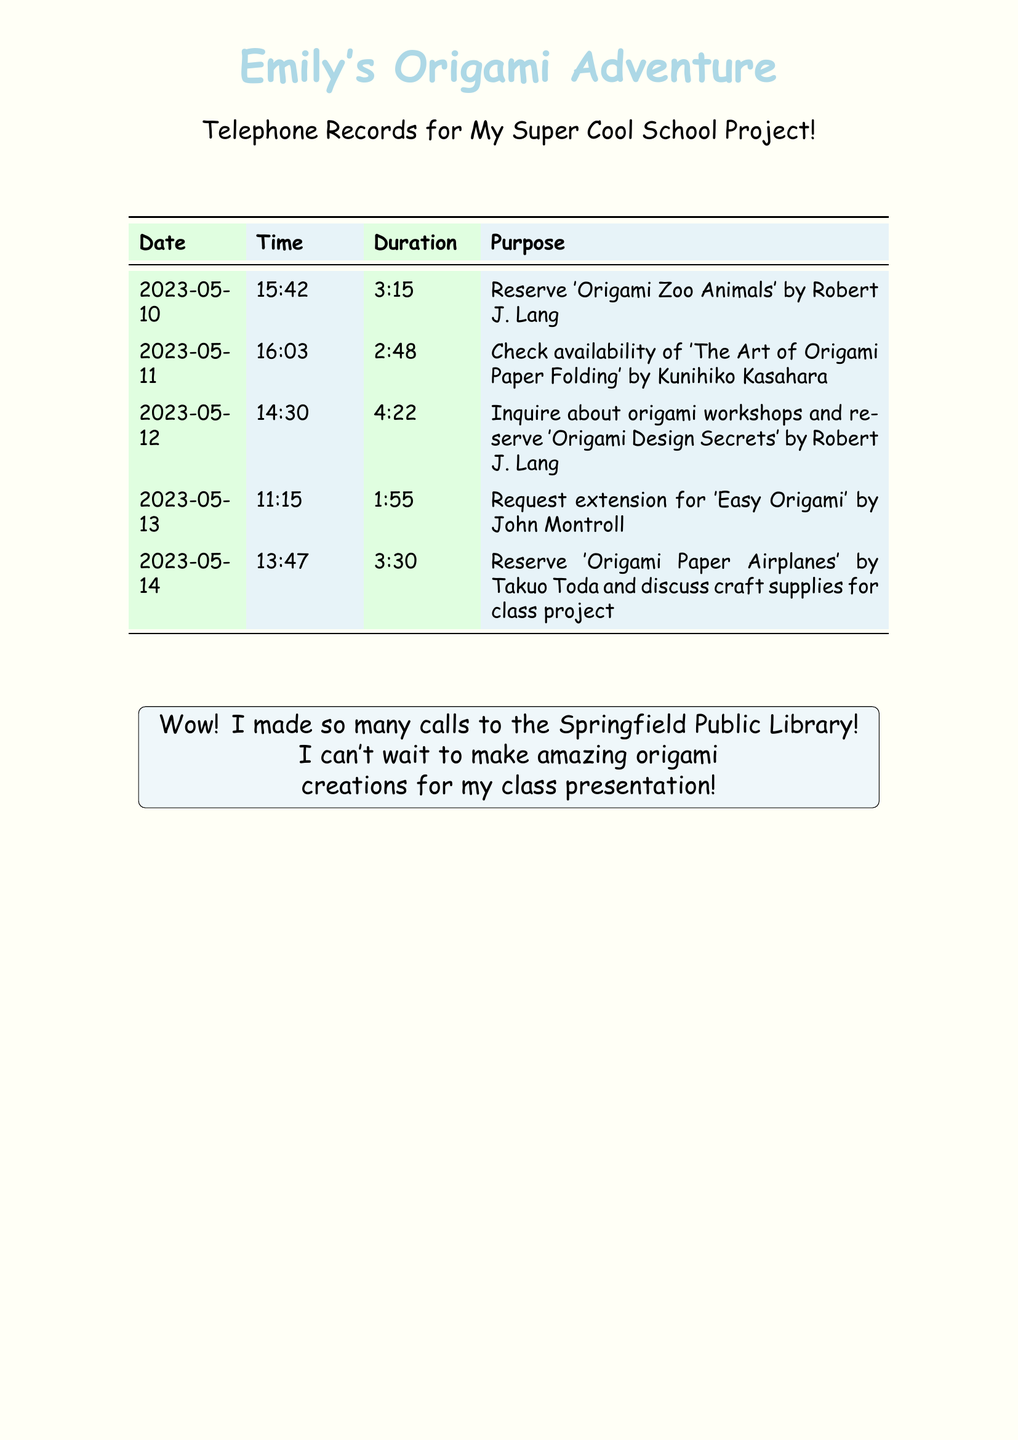What book was reserved on May 10? The book reserved on May 10 is 'Origami Zoo Animals' by Robert J. Lang.
Answer: 'Origami Zoo Animals' What was the duration of the call on May 12? The duration of the call on May 12 was 4 minutes and 22 seconds.
Answer: 4:22 Which book's availability was checked on May 11? The book's availability checked on May 11 was 'The Art of Origami Paper Folding' by Kunihiko Kasahara.
Answer: 'The Art of Origami Paper Folding' How many calls were made in total? There are five calls listed in the document.
Answer: 5 What was reserved on May 14? The book reserved on May 14 was 'Origami Paper Airplanes' by Takuo Toda.
Answer: 'Origami Paper Airplanes' What was the purpose of the call on May 12? The purpose of the call on May 12 was to inquire about origami workshops and reserve a book.
Answer: Inquire about origami workshops and reserve 'Origami Design Secrets' Which date had the shortest call duration? The shortest call duration was on May 13.
Answer: May 13 What did Emily discuss during her call on May 14? Emily discussed craft supplies for the class project during her call on May 14.
Answer: Craft supplies for class project What is the main focus of the telephone records? The main focus of the records is calls made to reserve books on origami techniques.
Answer: Reserve books on origami techniques 